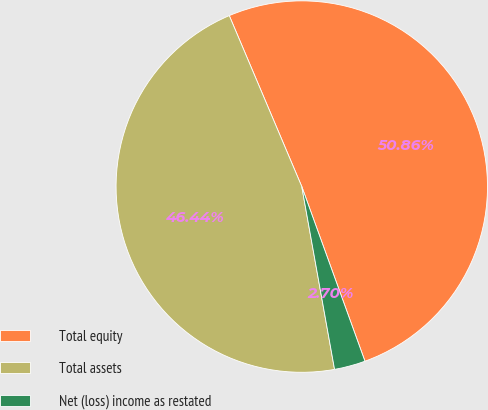Convert chart. <chart><loc_0><loc_0><loc_500><loc_500><pie_chart><fcel>Total equity<fcel>Total assets<fcel>Net (loss) income as restated<nl><fcel>50.86%<fcel>46.44%<fcel>2.7%<nl></chart> 